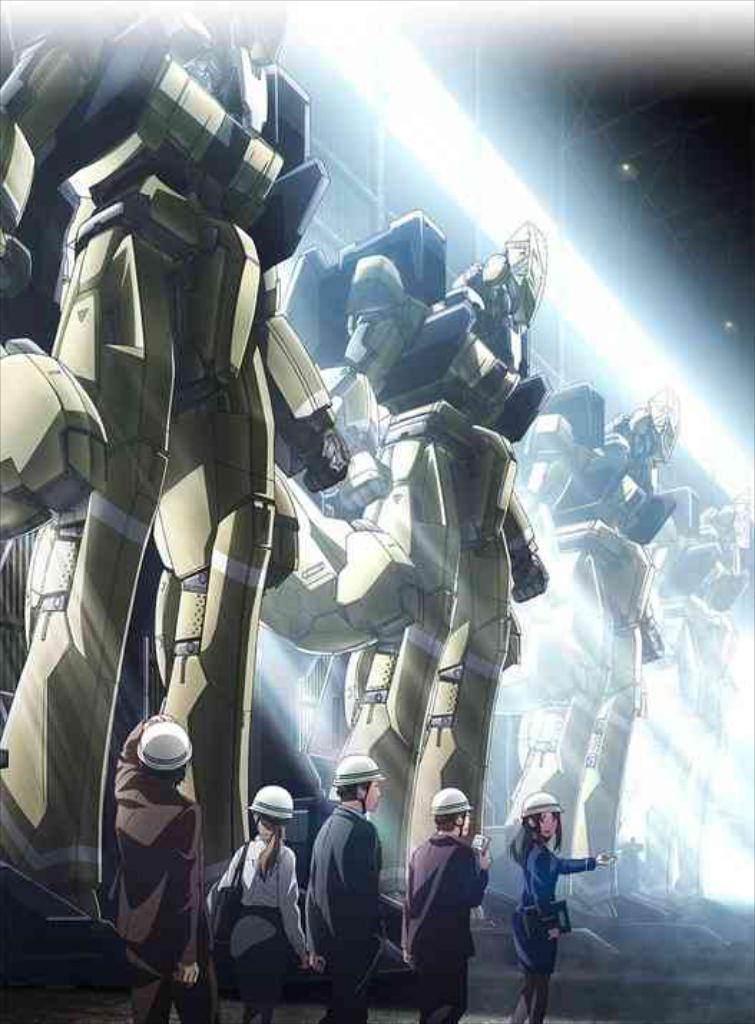What type of image is being described? The image is an animation. What can be seen happening on the floor in the image? There are persons on the floor in the image. What other objects or figures are present in the image? There are statues in the image. What type of soup is being served in the image? There is no soup present in the image; it is an animation featuring persons on the floor and statues. 